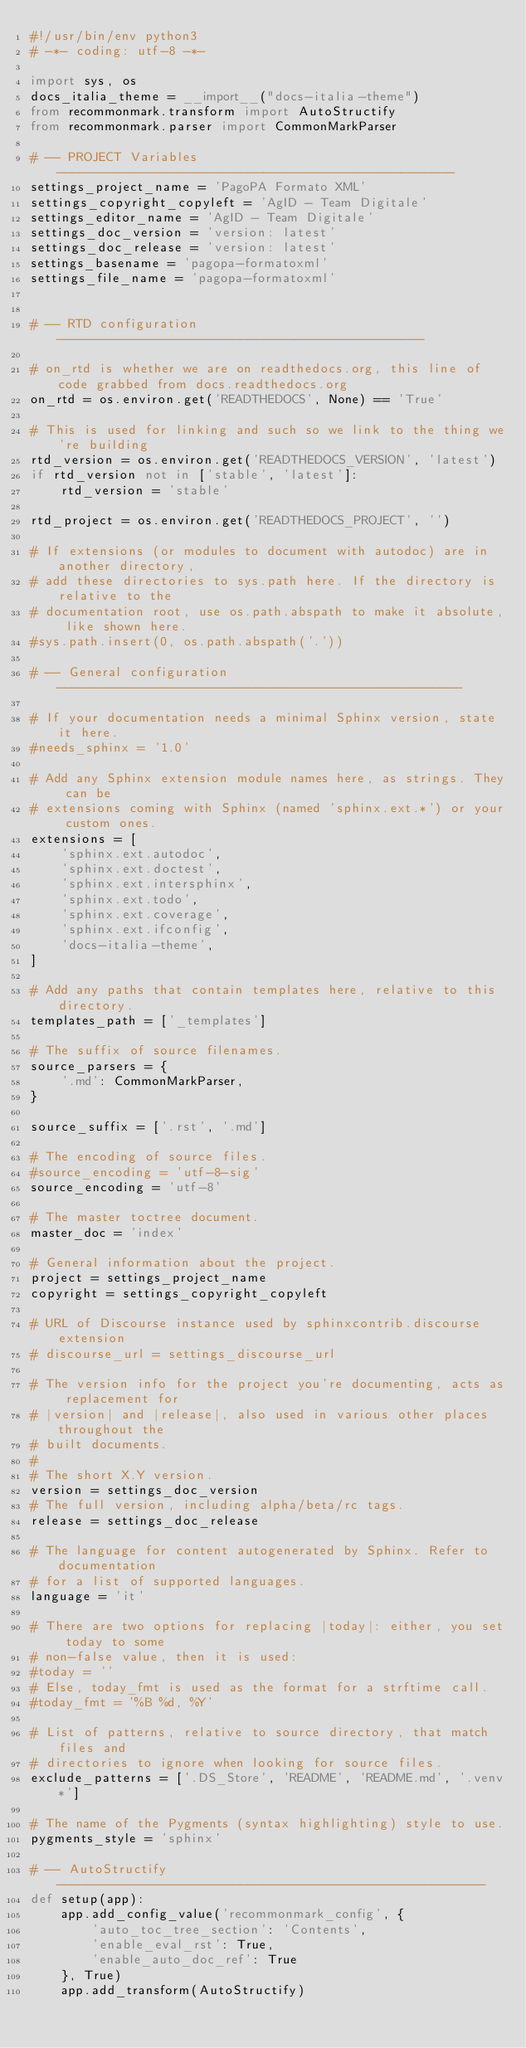<code> <loc_0><loc_0><loc_500><loc_500><_Python_>#!/usr/bin/env python3
# -*- coding: utf-8 -*-

import sys, os
docs_italia_theme = __import__("docs-italia-theme")
from recommonmark.transform import AutoStructify
from recommonmark.parser import CommonMarkParser

# -- PROJECT Variables ----------------------------------------------------
settings_project_name = 'PagoPA Formato XML'
settings_copyright_copyleft = 'AgID - Team Digitale'
settings_editor_name = 'AgID - Team Digitale'
settings_doc_version = 'version: latest'
settings_doc_release = 'version: latest'
settings_basename = 'pagopa-formatoxml'
settings_file_name = 'pagopa-formatoxml'


# -- RTD configuration ------------------------------------------------

# on_rtd is whether we are on readthedocs.org, this line of code grabbed from docs.readthedocs.org
on_rtd = os.environ.get('READTHEDOCS', None) == 'True'

# This is used for linking and such so we link to the thing we're building
rtd_version = os.environ.get('READTHEDOCS_VERSION', 'latest')
if rtd_version not in ['stable', 'latest']:
    rtd_version = 'stable'

rtd_project = os.environ.get('READTHEDOCS_PROJECT', '')

# If extensions (or modules to document with autodoc) are in another directory,
# add these directories to sys.path here. If the directory is relative to the
# documentation root, use os.path.abspath to make it absolute, like shown here.
#sys.path.insert(0, os.path.abspath('.'))

# -- General configuration -----------------------------------------------------

# If your documentation needs a minimal Sphinx version, state it here.
#needs_sphinx = '1.0'

# Add any Sphinx extension module names here, as strings. They can be
# extensions coming with Sphinx (named 'sphinx.ext.*') or your custom ones.
extensions = [
    'sphinx.ext.autodoc',
    'sphinx.ext.doctest',
    'sphinx.ext.intersphinx',
    'sphinx.ext.todo',
    'sphinx.ext.coverage',
    'sphinx.ext.ifconfig',
    'docs-italia-theme',
]

# Add any paths that contain templates here, relative to this directory.
templates_path = ['_templates']

# The suffix of source filenames.
source_parsers = {
    '.md': CommonMarkParser,
}

source_suffix = ['.rst', '.md']

# The encoding of source files.
#source_encoding = 'utf-8-sig'
source_encoding = 'utf-8'

# The master toctree document.
master_doc = 'index'

# General information about the project.
project = settings_project_name
copyright = settings_copyright_copyleft

# URL of Discourse instance used by sphinxcontrib.discourse extension
# discourse_url = settings_discourse_url

# The version info for the project you're documenting, acts as replacement for
# |version| and |release|, also used in various other places throughout the
# built documents.
#
# The short X.Y version.
version = settings_doc_version
# The full version, including alpha/beta/rc tags.
release = settings_doc_release

# The language for content autogenerated by Sphinx. Refer to documentation
# for a list of supported languages.
language = 'it'

# There are two options for replacing |today|: either, you set today to some
# non-false value, then it is used:
#today = ''
# Else, today_fmt is used as the format for a strftime call.
#today_fmt = '%B %d, %Y'

# List of patterns, relative to source directory, that match files and
# directories to ignore when looking for source files.
exclude_patterns = ['.DS_Store', 'README', 'README.md', '.venv*']

# The name of the Pygments (syntax highlighting) style to use.
pygments_style = 'sphinx'

# -- AutoStructify --------------------------------------------------------
def setup(app):
    app.add_config_value('recommonmark_config', {
        'auto_toc_tree_section': 'Contents',
        'enable_eval_rst': True,
        'enable_auto_doc_ref': True
    }, True)
    app.add_transform(AutoStructify)

</code> 